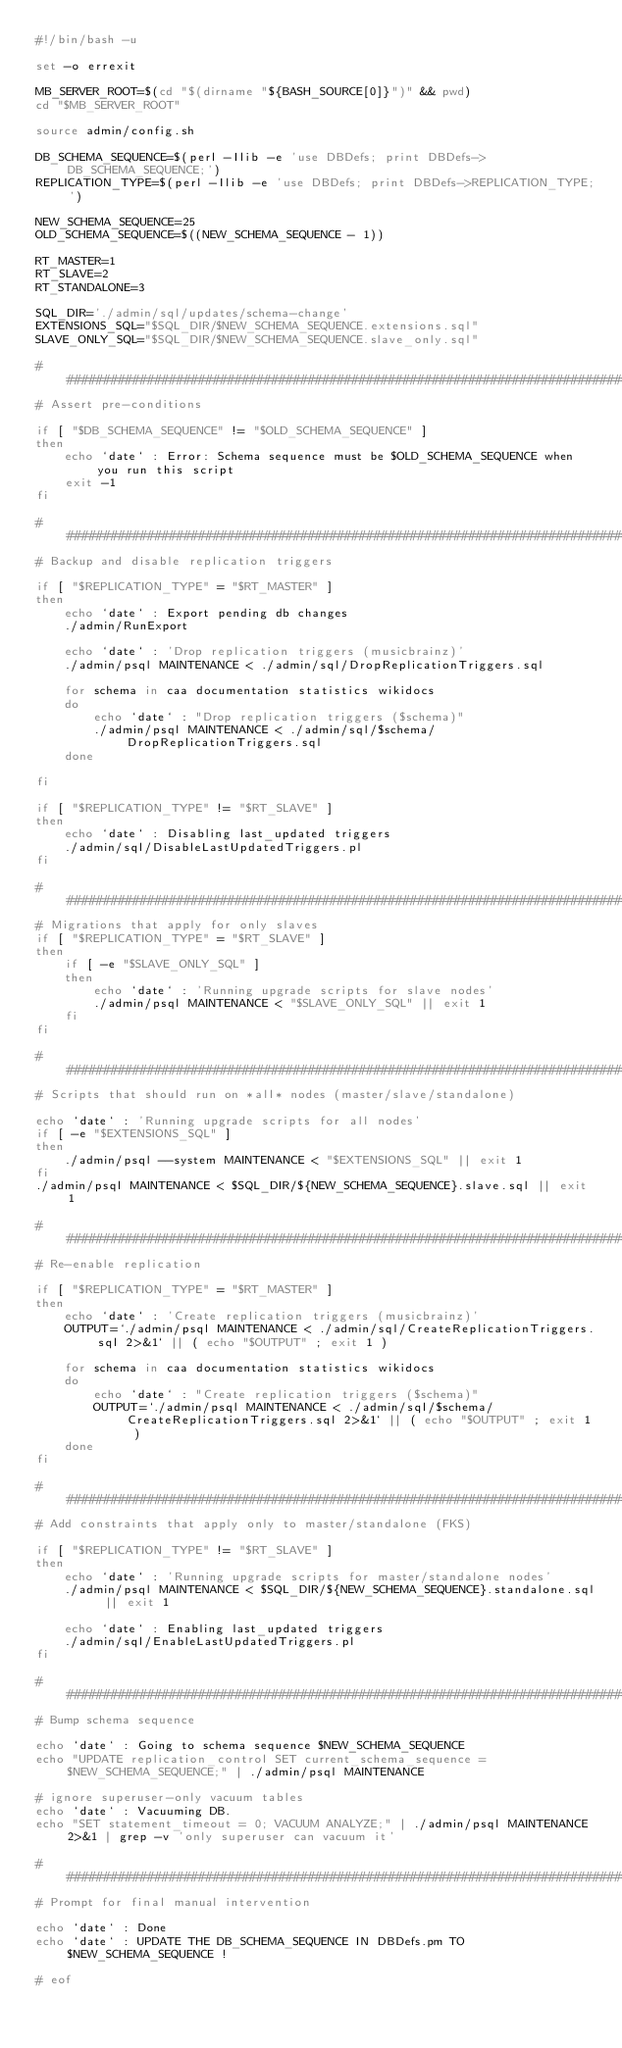<code> <loc_0><loc_0><loc_500><loc_500><_Bash_>#!/bin/bash -u

set -o errexit

MB_SERVER_ROOT=$(cd "$(dirname "${BASH_SOURCE[0]}")" && pwd)
cd "$MB_SERVER_ROOT"

source admin/config.sh

DB_SCHEMA_SEQUENCE=$(perl -Ilib -e 'use DBDefs; print DBDefs->DB_SCHEMA_SEQUENCE;')
REPLICATION_TYPE=$(perl -Ilib -e 'use DBDefs; print DBDefs->REPLICATION_TYPE;')

NEW_SCHEMA_SEQUENCE=25
OLD_SCHEMA_SEQUENCE=$((NEW_SCHEMA_SEQUENCE - 1))

RT_MASTER=1
RT_SLAVE=2
RT_STANDALONE=3

SQL_DIR='./admin/sql/updates/schema-change'
EXTENSIONS_SQL="$SQL_DIR/$NEW_SCHEMA_SEQUENCE.extensions.sql"
SLAVE_ONLY_SQL="$SQL_DIR/$NEW_SCHEMA_SEQUENCE.slave_only.sql"

################################################################################
# Assert pre-conditions

if [ "$DB_SCHEMA_SEQUENCE" != "$OLD_SCHEMA_SEQUENCE" ]
then
    echo `date` : Error: Schema sequence must be $OLD_SCHEMA_SEQUENCE when you run this script
    exit -1
fi

################################################################################
# Backup and disable replication triggers

if [ "$REPLICATION_TYPE" = "$RT_MASTER" ]
then
    echo `date` : Export pending db changes
    ./admin/RunExport

    echo `date` : 'Drop replication triggers (musicbrainz)'
    ./admin/psql MAINTENANCE < ./admin/sql/DropReplicationTriggers.sql

    for schema in caa documentation statistics wikidocs
    do
        echo `date` : "Drop replication triggers ($schema)"
        ./admin/psql MAINTENANCE < ./admin/sql/$schema/DropReplicationTriggers.sql
    done

fi

if [ "$REPLICATION_TYPE" != "$RT_SLAVE" ]
then
    echo `date` : Disabling last_updated triggers
    ./admin/sql/DisableLastUpdatedTriggers.pl
fi

################################################################################
# Migrations that apply for only slaves
if [ "$REPLICATION_TYPE" = "$RT_SLAVE" ]
then
    if [ -e "$SLAVE_ONLY_SQL" ]
    then
        echo `date` : 'Running upgrade scripts for slave nodes'
        ./admin/psql MAINTENANCE < "$SLAVE_ONLY_SQL" || exit 1
    fi
fi

################################################################################
# Scripts that should run on *all* nodes (master/slave/standalone)

echo `date` : 'Running upgrade scripts for all nodes'
if [ -e "$EXTENSIONS_SQL" ]
then
    ./admin/psql --system MAINTENANCE < "$EXTENSIONS_SQL" || exit 1
fi
./admin/psql MAINTENANCE < $SQL_DIR/${NEW_SCHEMA_SEQUENCE}.slave.sql || exit 1

################################################################################
# Re-enable replication

if [ "$REPLICATION_TYPE" = "$RT_MASTER" ]
then
    echo `date` : 'Create replication triggers (musicbrainz)'
    OUTPUT=`./admin/psql MAINTENANCE < ./admin/sql/CreateReplicationTriggers.sql 2>&1` || ( echo "$OUTPUT" ; exit 1 )

    for schema in caa documentation statistics wikidocs
    do
        echo `date` : "Create replication triggers ($schema)"
        OUTPUT=`./admin/psql MAINTENANCE < ./admin/sql/$schema/CreateReplicationTriggers.sql 2>&1` || ( echo "$OUTPUT" ; exit 1 )
    done
fi

################################################################################
# Add constraints that apply only to master/standalone (FKS)

if [ "$REPLICATION_TYPE" != "$RT_SLAVE" ]
then
    echo `date` : 'Running upgrade scripts for master/standalone nodes'
    ./admin/psql MAINTENANCE < $SQL_DIR/${NEW_SCHEMA_SEQUENCE}.standalone.sql || exit 1

    echo `date` : Enabling last_updated triggers
    ./admin/sql/EnableLastUpdatedTriggers.pl
fi

################################################################################
# Bump schema sequence

echo `date` : Going to schema sequence $NEW_SCHEMA_SEQUENCE
echo "UPDATE replication_control SET current_schema_sequence = $NEW_SCHEMA_SEQUENCE;" | ./admin/psql MAINTENANCE

# ignore superuser-only vacuum tables
echo `date` : Vacuuming DB.
echo "SET statement_timeout = 0; VACUUM ANALYZE;" | ./admin/psql MAINTENANCE 2>&1 | grep -v 'only superuser can vacuum it'

################################################################################
# Prompt for final manual intervention

echo `date` : Done
echo `date` : UPDATE THE DB_SCHEMA_SEQUENCE IN DBDefs.pm TO $NEW_SCHEMA_SEQUENCE !

# eof
</code> 